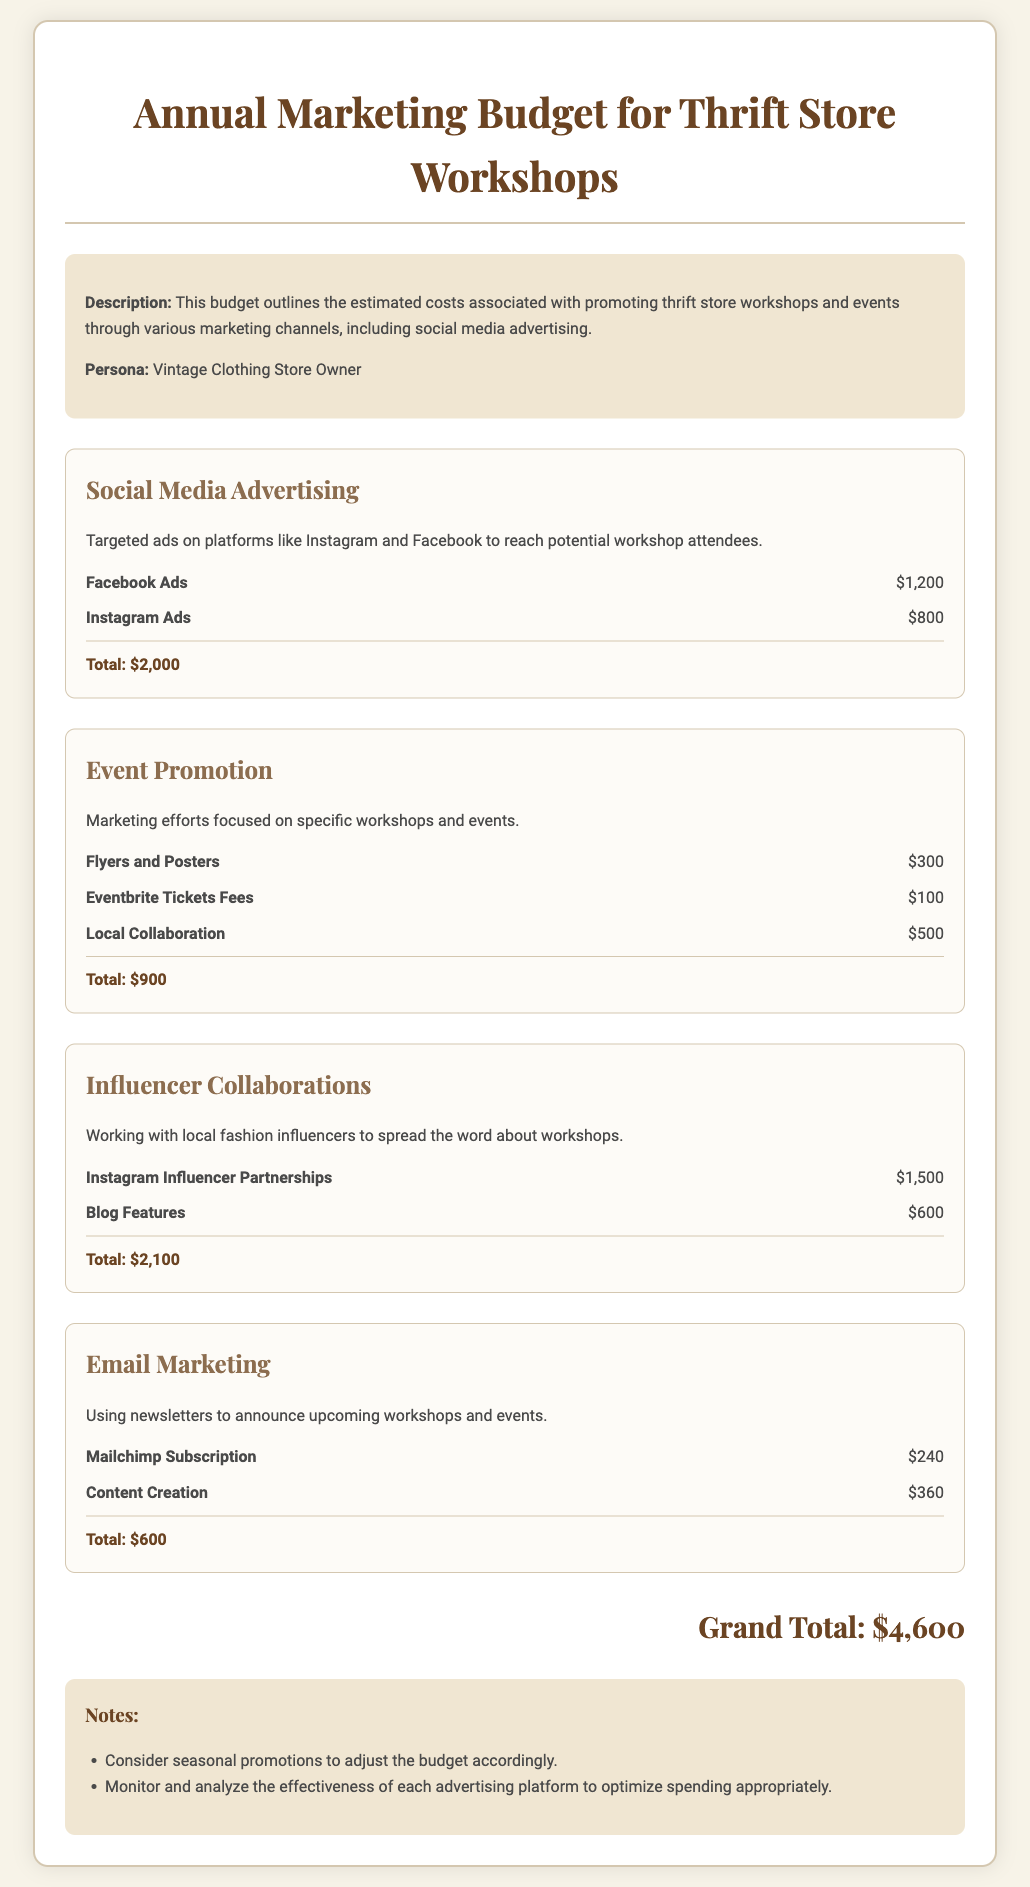What is the total budget for Social Media Advertising? The total budget for Social Media Advertising is stated in the document, combining the costs of Facebook Ads and Instagram Ads.
Answer: $2,000 How much is allocated for Email Marketing? The document shows the budget items related to Email Marketing, including Mailchimp Subscription and Content Creation.
Answer: $600 What is the cost of Instagram Influencer Partnerships? The document lists the budget item for Instagram Influencer Partnerships under Influencer Collaborations.
Answer: $1,500 What is the Grand Total of the budget? The Grand Total is the sum of all budget categories mentioned in the document.
Answer: $4,600 How much is budgeted for Flyers and Posters? The budget for Flyers and Posters is included in the Event Promotion section of the document.
Answer: $300 What marketing effort is specifically mentioned under the Event Promotion category? The document outlines specific marketing efforts in the Event Promotion category, including Flyers and Posters.
Answer: Flyers and Posters What is the cost for Mailchimp Subscription? The document provides the cost for Mailchimp Subscription under the Email Marketing section.
Answer: $240 What type of marketing is emphasized in the summary of the document? The summary highlights the focus on promoting thrift store workshops and events through various marketing channels.
Answer: Promoting workshops and events What strategy is suggested to adjust the budget? The notes section suggests considering seasonal promotions for budget adjustments.
Answer: Seasonal promotions 